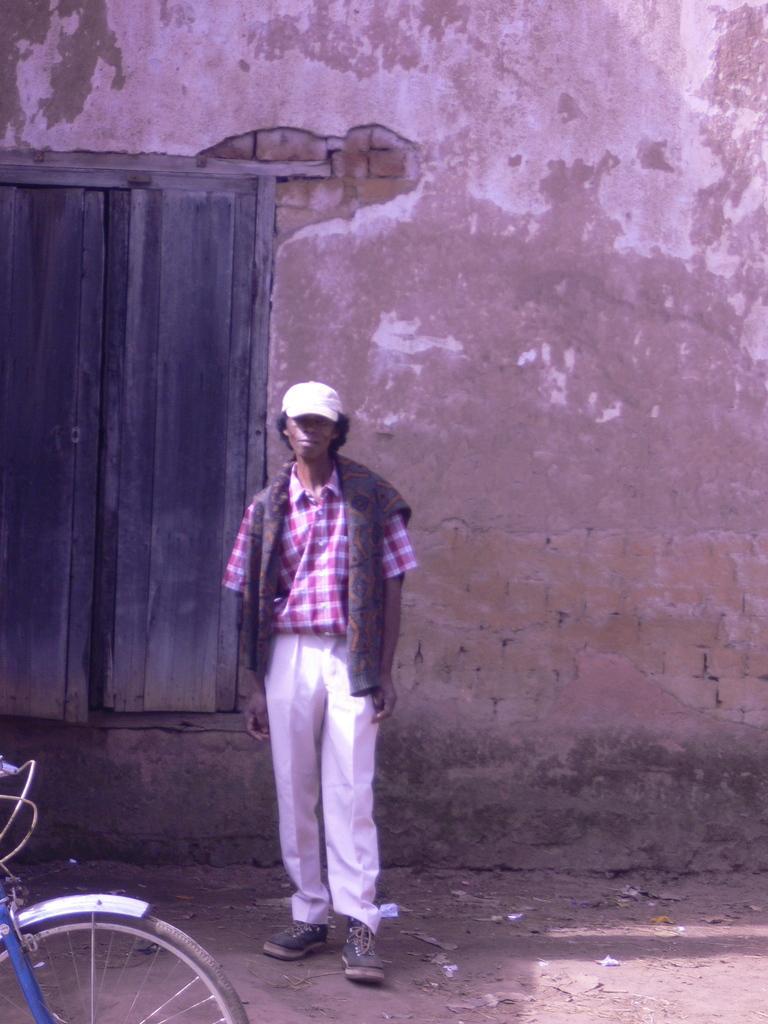Can you describe this image briefly? In this image we can see a person standing on the ground. In the background there is a door and also a wall. On the left there is a bicycle. 